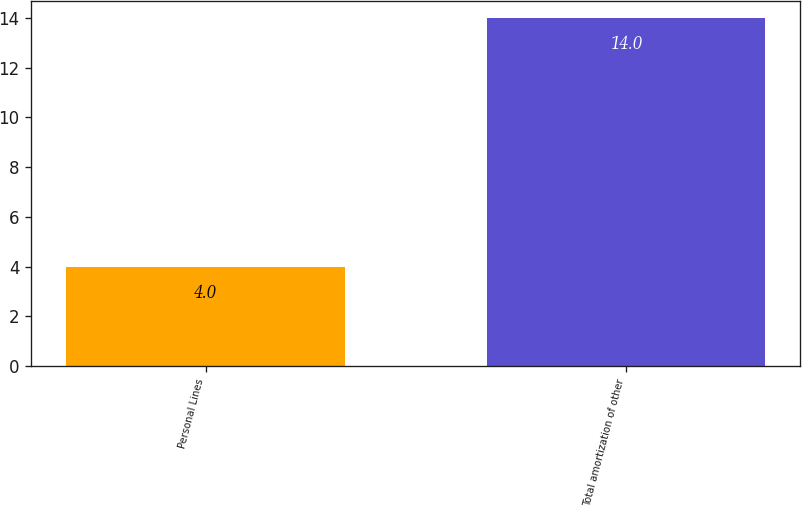Convert chart. <chart><loc_0><loc_0><loc_500><loc_500><bar_chart><fcel>Personal Lines<fcel>Total amortization of other<nl><fcel>4<fcel>14<nl></chart> 